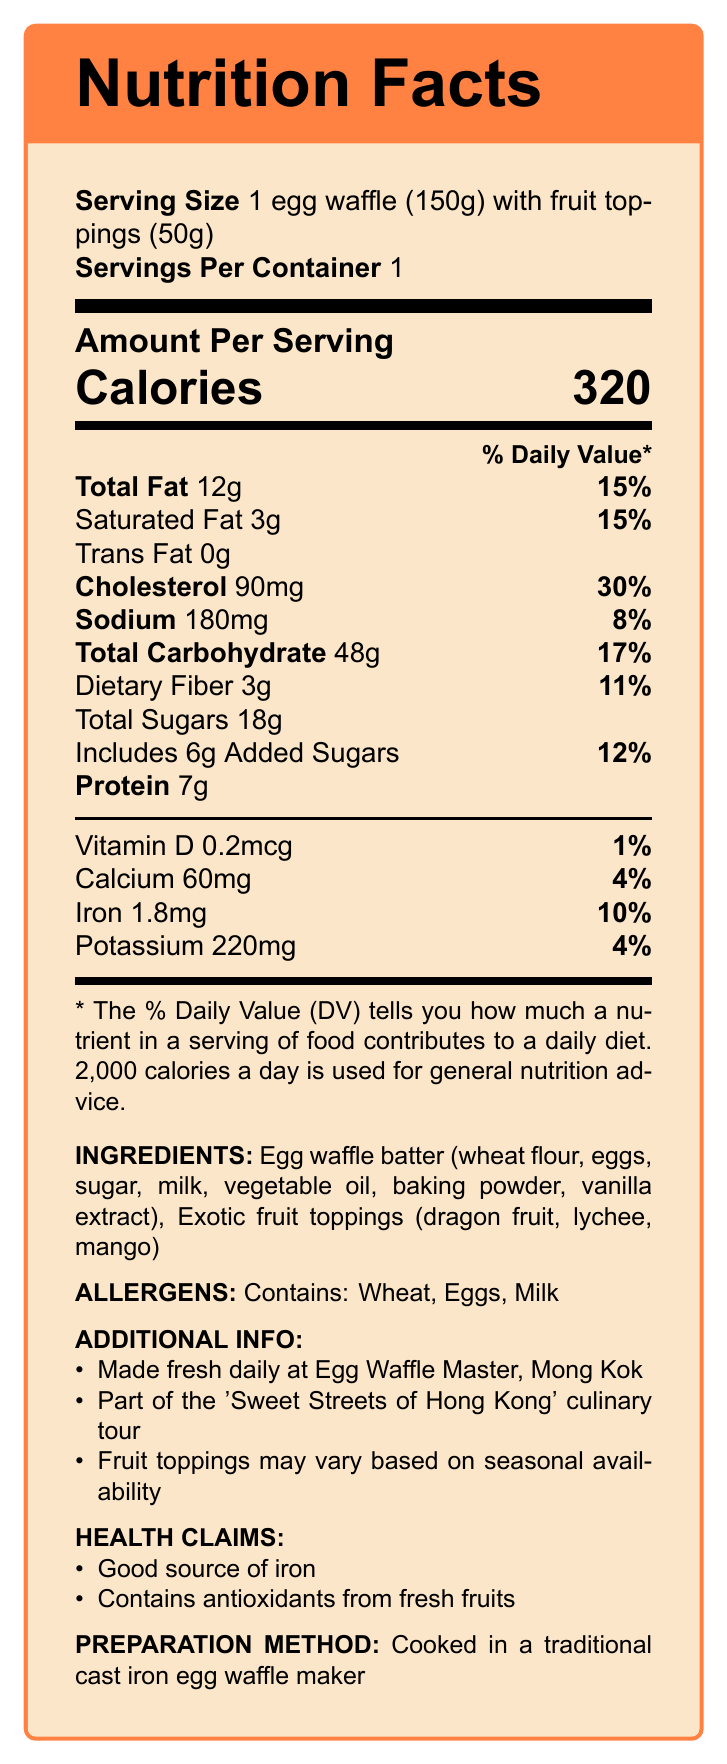what is the serving size? The serving size is listed at the top of the document.
Answer: 1 egg waffle (150g) with fruit toppings (50g) how many calories are in one serving? The document states that there are 320 calories per serving.
Answer: 320 what is the total fat content per serving? The total fat content per serving is shown in the nutritional breakdown.
Answer: 12g what is the percentage of daily value for cholesterol? The percentage of daily value for cholesterol is stated directly beside the amount (90mg).
Answer: 30% which fruit toppings are included in the ingredients? The ingredients section lists the exotic fruit toppings as dragon fruit, lychee, and mango.
Answer: Dragon fruit, lychee, mango which allergens are contained in the egg waffle? The allergens section specifies that the egg waffle contains wheat, eggs, and milk.
Answer: Wheat, Eggs, Milk how much iron is in one serving? The document lists the amount of iron per serving as 1.8mg.
Answer: 1.8mg what are the health claims associated with this food product? The health claims section mentions these specific benefits.
Answer: Good source of iron, Contains antioxidants from fresh fruits what is the preparation method for the egg waffle? The preparation method is stated clearly at the bottom of the document.
Answer: Cooked in a traditional cast iron egg waffle maker how much added sugar does the egg waffle contain? The document shows that there are 6g of added sugars.
Answer: 6g what is the total carbohydrate content per serving? The total carbohydrate content per serving is listed as 48g.
Answer: 48g where is this egg waffle made? A. Mong Kok B. Tsim Sha Tsui C. Central The additional information section states that the egg waffle is made fresh daily at Egg Waffle Master in Mong Kok.
Answer: A. Mong Kok what is the sodium content in one serving? A. 150mg B. 180mg C. 210mg The sodium content per serving is listed as 180mg.
Answer: B. 180mg is the egg waffle a good source of potassium? The document shows that the egg waffle only contains 220mg of potassium which is 4% of the daily value, not enough to be considered a good source.
Answer: No is there any trans fat in one serving of the egg waffle? The document shows that the trans fat content per serving is 0g.
Answer: No describe the main idea of the Nutrition Facts Label for the traditional Hong Kong egg waffle with exotic fruit toppings. The document outlines the nutritional content and additional details of the egg waffle, helping consumers make informed dietary choices.
Answer: The Nutrition Facts Label provides details on the serving size, calories, and nutrient breakdown including fat, cholesterol, sodium, carbohydrates, sugars, protein, and various vitamins and minerals. It lists the ingredients, allergens, preparation method, additional information such as where it is made, and associated health claims. how many servings does the container have? The document states that there is 1 serving per container.
Answer: 1 what percentage of the daily value of vitamin D does one serving of the egg waffle provide? The document shows that one serving provides 0.2mcg of vitamin D, which is 1% of the daily value.
Answer: 1% are the fruit toppings always the same? The additional information section notes that fruit toppings may vary based on seasonal availability.
Answer: No is the egg waffle batter gluten-free? The ingredients section lists wheat flour, indicating that the egg waffle is not gluten-free.
Answer: No how many grams of dietary fiber are in one serving? The dietary fiber content per serving is listed as 3g.
Answer: 3g how is the document laid out visually? The document uses a visually organized format with clear sections and headings to present the nutritional information.
Answer: The document uses a tcolorbox to display the Nutrition Facts Label with a layout that includes the serving size, servings per container, calories, % daily values of various nutrients, ingredients, allergens, additional information, health claims, and the preparation method. A colorful and structured format helps in understanding the nutritional information easily. does the egg waffle provide a significant percentage of the daily recommended calcium intake? The egg waffle contains 60mg of calcium, which is only 4% of the daily recommended intake.
Answer: No 